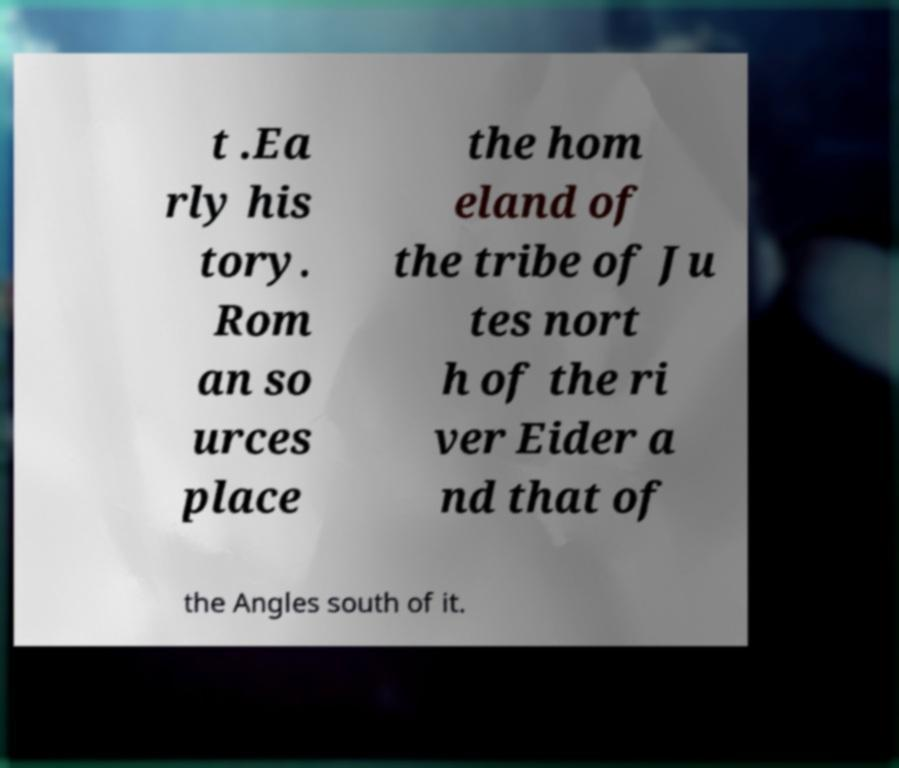There's text embedded in this image that I need extracted. Can you transcribe it verbatim? t .Ea rly his tory. Rom an so urces place the hom eland of the tribe of Ju tes nort h of the ri ver Eider a nd that of the Angles south of it. 